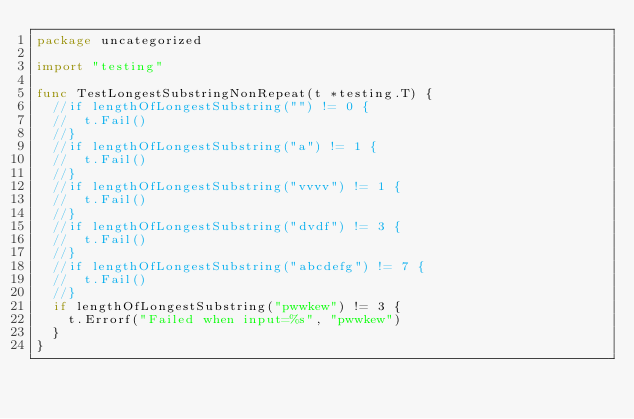<code> <loc_0><loc_0><loc_500><loc_500><_Go_>package uncategorized

import "testing"

func TestLongestSubstringNonRepeat(t *testing.T) {
	//if lengthOfLongestSubstring("") != 0 {
	//	t.Fail()
	//}
	//if lengthOfLongestSubstring("a") != 1 {
	//	t.Fail()
	//}
	//if lengthOfLongestSubstring("vvvv") != 1 {
	//	t.Fail()
	//}
	//if lengthOfLongestSubstring("dvdf") != 3 {
	//	t.Fail()
	//}
	//if lengthOfLongestSubstring("abcdefg") != 7 {
	//	t.Fail()
	//}
	if lengthOfLongestSubstring("pwwkew") != 3 {
		t.Errorf("Failed when input=%s", "pwwkew")
	}
}</code> 